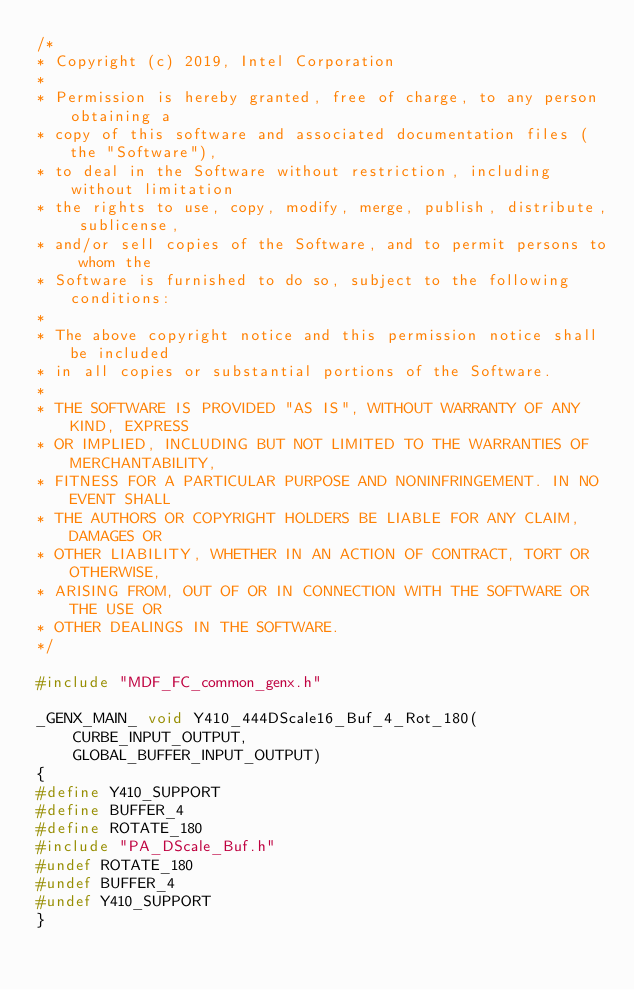Convert code to text. <code><loc_0><loc_0><loc_500><loc_500><_C++_>/*
* Copyright (c) 2019, Intel Corporation
*
* Permission is hereby granted, free of charge, to any person obtaining a
* copy of this software and associated documentation files (the "Software"),
* to deal in the Software without restriction, including without limitation
* the rights to use, copy, modify, merge, publish, distribute, sublicense,
* and/or sell copies of the Software, and to permit persons to whom the
* Software is furnished to do so, subject to the following conditions:
*
* The above copyright notice and this permission notice shall be included
* in all copies or substantial portions of the Software.
*
* THE SOFTWARE IS PROVIDED "AS IS", WITHOUT WARRANTY OF ANY KIND, EXPRESS
* OR IMPLIED, INCLUDING BUT NOT LIMITED TO THE WARRANTIES OF MERCHANTABILITY,
* FITNESS FOR A PARTICULAR PURPOSE AND NONINFRINGEMENT. IN NO EVENT SHALL
* THE AUTHORS OR COPYRIGHT HOLDERS BE LIABLE FOR ANY CLAIM, DAMAGES OR
* OTHER LIABILITY, WHETHER IN AN ACTION OF CONTRACT, TORT OR OTHERWISE,
* ARISING FROM, OUT OF OR IN CONNECTION WITH THE SOFTWARE OR THE USE OR
* OTHER DEALINGS IN THE SOFTWARE.
*/

#include "MDF_FC_common_genx.h"

_GENX_MAIN_ void Y410_444DScale16_Buf_4_Rot_180(
    CURBE_INPUT_OUTPUT,
    GLOBAL_BUFFER_INPUT_OUTPUT)
{
#define Y410_SUPPORT
#define BUFFER_4
#define ROTATE_180
#include "PA_DScale_Buf.h"
#undef ROTATE_180
#undef BUFFER_4
#undef Y410_SUPPORT
}</code> 